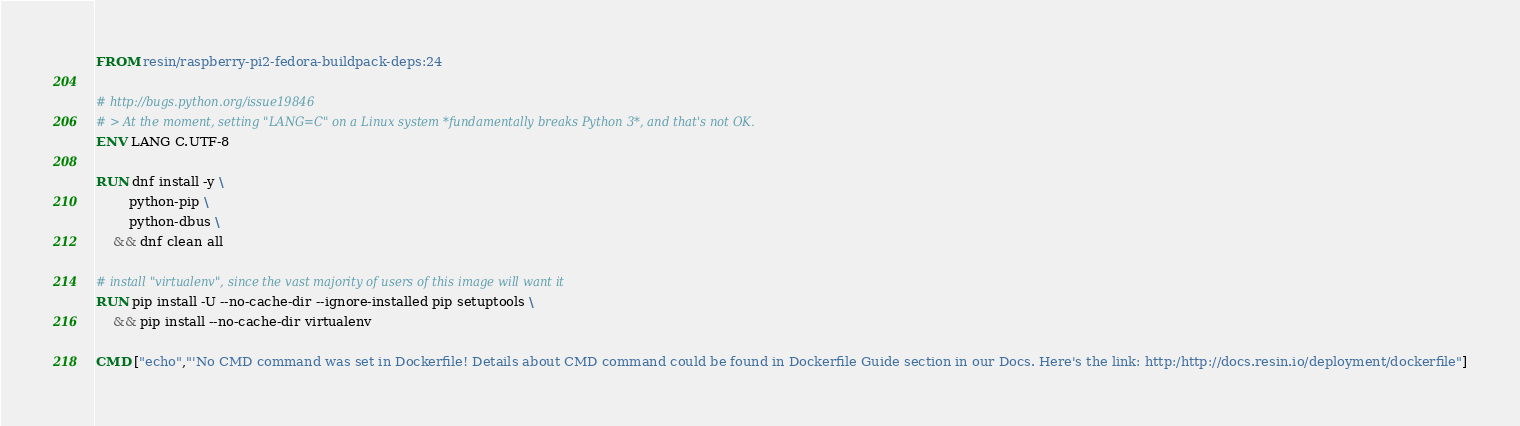<code> <loc_0><loc_0><loc_500><loc_500><_Dockerfile_>FROM resin/raspberry-pi2-fedora-buildpack-deps:24

# http://bugs.python.org/issue19846
# > At the moment, setting "LANG=C" on a Linux system *fundamentally breaks Python 3*, and that's not OK.
ENV LANG C.UTF-8

RUN dnf install -y \
		python-pip \
		python-dbus \
	&& dnf clean all

# install "virtualenv", since the vast majority of users of this image will want it
RUN pip install -U --no-cache-dir --ignore-installed pip setuptools \
	&& pip install --no-cache-dir virtualenv

CMD ["echo","'No CMD command was set in Dockerfile! Details about CMD command could be found in Dockerfile Guide section in our Docs. Here's the link: http:/http://docs.resin.io/deployment/dockerfile"]
</code> 